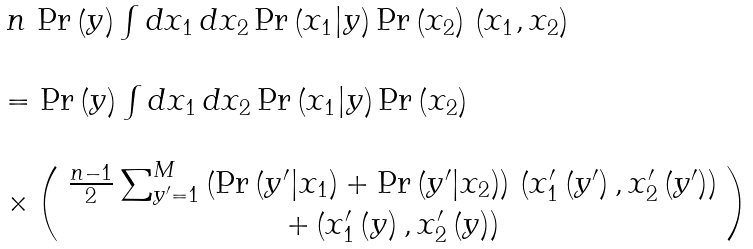Convert formula to latex. <formula><loc_0><loc_0><loc_500><loc_500>\begin{array} { l } n \, \Pr \left ( y \right ) \int d x _ { 1 } \, d x _ { 2 } \Pr \left ( x _ { 1 } | y \right ) \Pr \left ( x _ { 2 } \right ) \, \left ( x _ { 1 } , x _ { 2 } \right ) \\ \\ = \Pr \left ( y \right ) \int d x _ { 1 } \, d x _ { 2 } \Pr \left ( x _ { 1 } | y \right ) \Pr \left ( x _ { 2 } \right ) \\ \\ \times \left ( \begin{array} { c } \frac { n - 1 } { 2 } \sum _ { y ^ { \prime } = 1 } ^ { M } \left ( \Pr \left ( y ^ { \prime } | x _ { 1 } \right ) + \Pr \left ( y ^ { \prime } | x _ { 2 } \right ) \right ) \, \left ( x _ { 1 } ^ { \prime } \left ( y ^ { \prime } \right ) , x _ { 2 } ^ { \prime } \left ( y ^ { \prime } \right ) \right ) \\ + \left ( x _ { 1 } ^ { \prime } \left ( y \right ) , x _ { 2 } ^ { \prime } \left ( y \right ) \right ) \end{array} \right ) \end{array} \quad \ \</formula> 